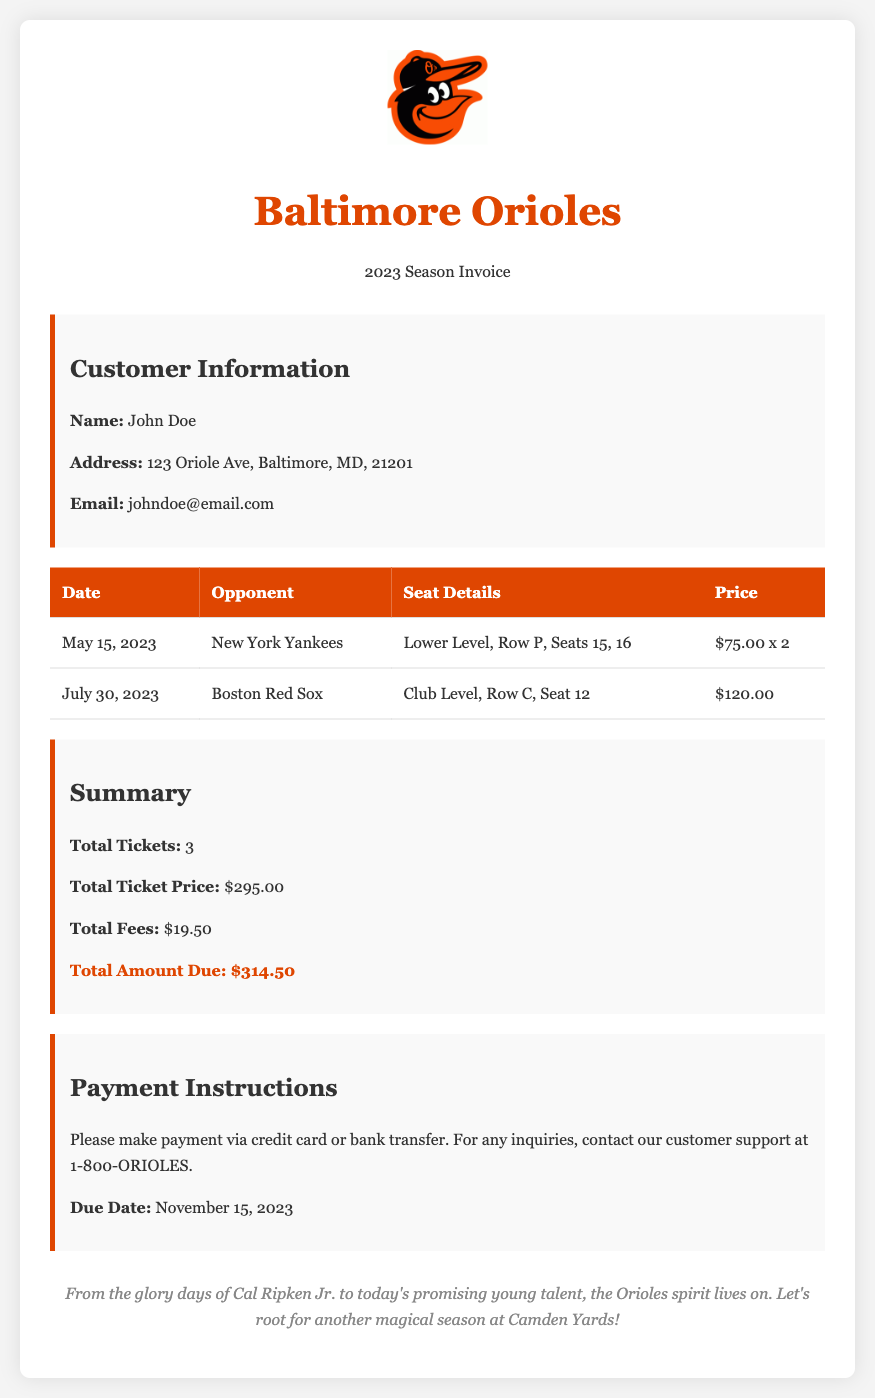What is the total ticket price? The total ticket price is the sum of ticket prices listed in the table, which is $75.00 x 2 + $120.00 = $295.00.
Answer: $295.00 What is the due date for the payment? The due date for the payment is specified in the payment instructions section of the document.
Answer: November 15, 2023 How many tickets did John Doe purchase? The document states that John Doe purchased a total of 3 tickets.
Answer: 3 What is the price for the Boston Red Sox game? The Boston Red Sox game's price is detailed in the table under the respective date.
Answer: $120.00 What are the seat details for the New York Yankees game? The seat details for the New York Yankees game are mentioned in the table alongside the date and opponent.
Answer: Lower Level, Row P, Seats 15, 16 What is the total amount due? The total amount due is highlighted in the summary section of the document.
Answer: $314.50 What is the customer’s name? The customer’s name is listed in the customer information section.
Answer: John Doe What type of seating is provided for the New York Yankees game? The type of seating for the New York Yankees game is indicated in the seat details within the table.
Answer: Lower Level 